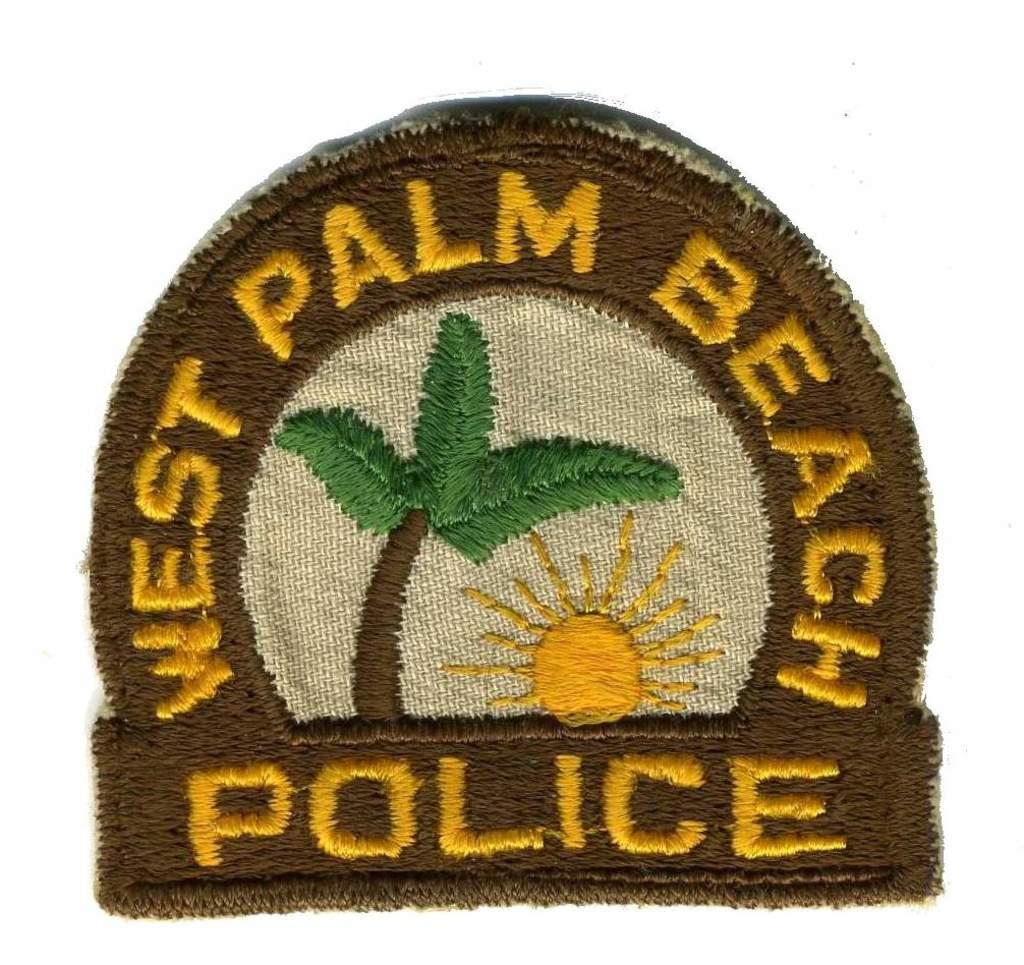What police area is this?
Your answer should be compact. West palm beach. 